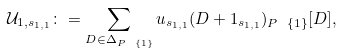<formula> <loc_0><loc_0><loc_500><loc_500>\mathcal { U } _ { 1 , s _ { 1 , 1 } } \colon = \sum _ { D \in \Delta _ { P \ \{ 1 \} } } u _ { s _ { 1 , 1 } } ( D + 1 _ { s _ { 1 , 1 } } ) _ { P \ \{ 1 \} } [ D ] ,</formula> 